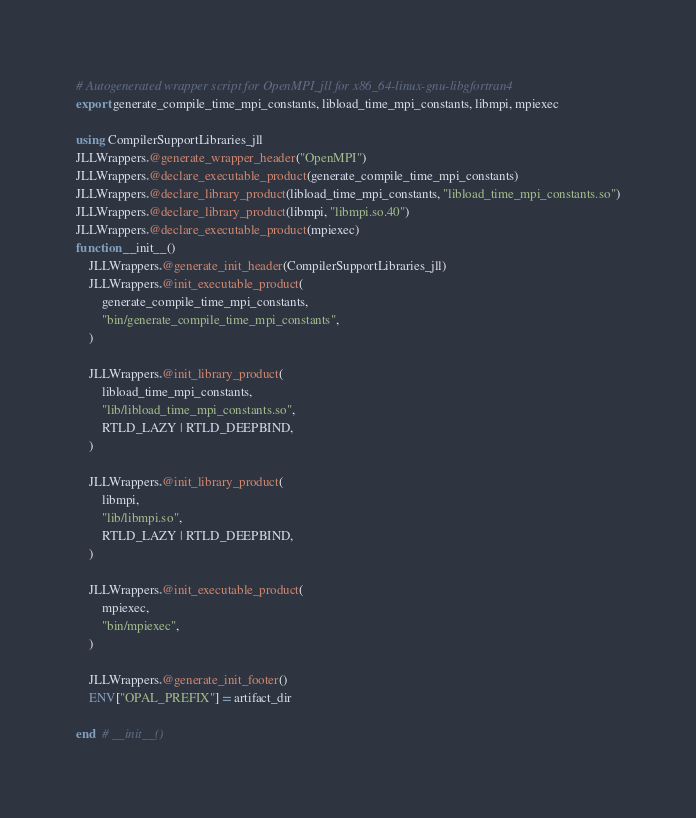Convert code to text. <code><loc_0><loc_0><loc_500><loc_500><_Julia_># Autogenerated wrapper script for OpenMPI_jll for x86_64-linux-gnu-libgfortran4
export generate_compile_time_mpi_constants, libload_time_mpi_constants, libmpi, mpiexec

using CompilerSupportLibraries_jll
JLLWrappers.@generate_wrapper_header("OpenMPI")
JLLWrappers.@declare_executable_product(generate_compile_time_mpi_constants)
JLLWrappers.@declare_library_product(libload_time_mpi_constants, "libload_time_mpi_constants.so")
JLLWrappers.@declare_library_product(libmpi, "libmpi.so.40")
JLLWrappers.@declare_executable_product(mpiexec)
function __init__()
    JLLWrappers.@generate_init_header(CompilerSupportLibraries_jll)
    JLLWrappers.@init_executable_product(
        generate_compile_time_mpi_constants,
        "bin/generate_compile_time_mpi_constants",
    )

    JLLWrappers.@init_library_product(
        libload_time_mpi_constants,
        "lib/libload_time_mpi_constants.so",
        RTLD_LAZY | RTLD_DEEPBIND,
    )

    JLLWrappers.@init_library_product(
        libmpi,
        "lib/libmpi.so",
        RTLD_LAZY | RTLD_DEEPBIND,
    )

    JLLWrappers.@init_executable_product(
        mpiexec,
        "bin/mpiexec",
    )

    JLLWrappers.@generate_init_footer()
    ENV["OPAL_PREFIX"] = artifact_dir

end  # __init__()
</code> 